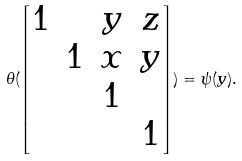Convert formula to latex. <formula><loc_0><loc_0><loc_500><loc_500>\theta ( \begin{bmatrix} 1 & & y & z \\ & 1 & x & y \\ & & 1 & \\ & & & 1 \end{bmatrix} ) = \psi ( y ) .</formula> 